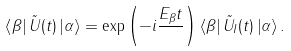Convert formula to latex. <formula><loc_0><loc_0><loc_500><loc_500>\left < \beta \right | \tilde { U } ( t ) \left | \alpha \right > = \exp \left ( - i \frac { E _ { \beta } t } { } \right ) \left < \beta \right | \tilde { U } _ { I } ( t ) \left | \alpha \right > .</formula> 